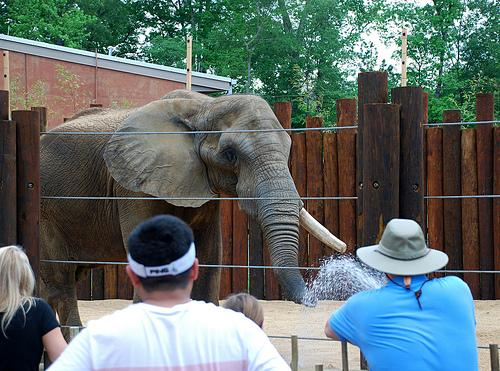Enumerate the visible clothing items and accessories worn by the man in the image. The man has on a baby blue shirt, white headband, khaki hat, and possibly a gray hat. What type of enclosure is the elephant in? Specify the material used for it. The elephant is in a pen with a brown wooden fence and metal wire attached to wooden posts. Mention the primary action performed by the elephant in the image. The elephant is walking forward and spitting out water from its trunk. How many elephants are in the image, and what unique features can be observed about it? There is one elephant in the image with one large ear, one tusk, a long trunk, and a hump. Assess the quality of the image based on the level of detail and clarity of the objects. The image has high quality with detailed and clear depictions of the objects and their interactions. Analyze the setting of the image by mentioning the ground and background elements. The ground is dirt, and there are trees behind the wooden fence in the background. Identify the two people in the image and describe their appearances. There is a man wearing a baby blue shirt, white headband, and khaki hat, and a woman with blonde hair. Briefly describe the scene taking place in the image. The scene shows an elephant walking behind a wooden fence while spitting water, and a man and a woman observe nearby. Determine the mood or sentiment portrayed in the image based on the elements and actions. The image portrays a mood of curiosity and interaction between the humans and the elephant in a captive setting. Count the number of objects related to clothing or accessories in the image. There are 11 clothing or accessory related objects, including various shirts, hats, and headbands. 